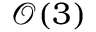<formula> <loc_0><loc_0><loc_500><loc_500>\mathcal { O } ( 3 )</formula> 